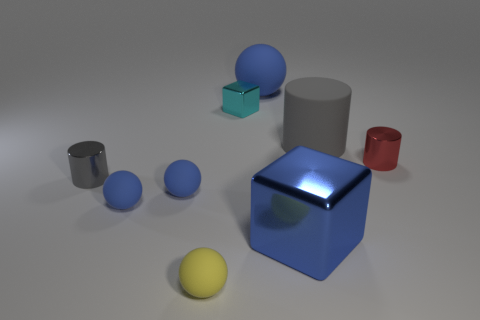Can you describe the texture and reflections on the surface of the objects? The objects in the image have a simulated texture that gives them a realistic appearance. The blue cube, in particular, has a highly reflective surface that mimics the glossy finish of polished materials. Reflections on its surface suggest a well-lit room, while the red cylinder and gray cylinder have more diffused reflections indicative of a metallic texture. How does the lighting in the scene affect the look of the objects? The lighting in the scene appears to be coming from above, casting subtle shadows directly underneath the objects. This overhead lighting accentuates the shapes of the objects, their material properties, and gives depth to the entire composition. Soft shadows also indicate a diffused light source, which softens contrasts and contributes to the overall calm and balanced atmosphere of the image. 